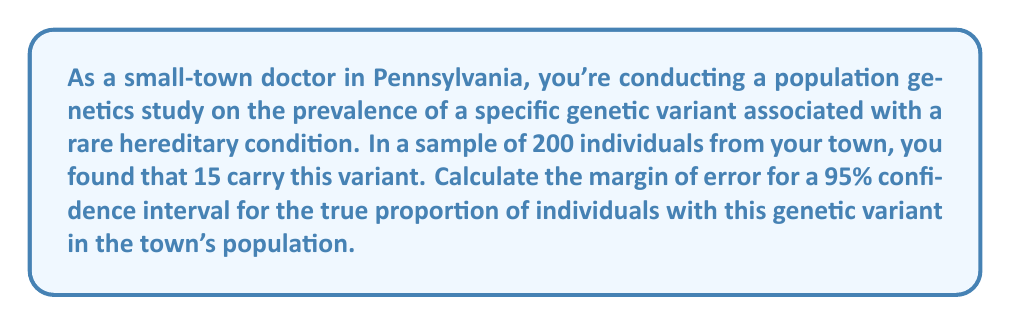Show me your answer to this math problem. Let's approach this step-by-step:

1) The margin of error (ME) for a confidence interval is calculated using the formula:

   $$ ME = z \sqrt{\frac{p(1-p)}{n}} $$

   Where:
   - $z$ is the z-score for the desired confidence level
   - $p$ is the sample proportion
   - $n$ is the sample size

2) For a 95% confidence interval, $z = 1.96$

3) Calculate the sample proportion $p$:
   $$ p = \frac{15}{200} = 0.075 $$

4) Now we can plug these values into our formula:

   $$ ME = 1.96 \sqrt{\frac{0.075(1-0.075)}{200}} $$

5) Simplify inside the square root:
   $$ ME = 1.96 \sqrt{\frac{0.075(0.925)}{200}} = 1.96 \sqrt{\frac{0.069375}{200}} $$

6) Calculate:
   $$ ME = 1.96 \sqrt{0.00034688} = 1.96 * 0.018624 = 0.0365 $$

7) Round to 3 decimal places:
   $$ ME \approx 0.037 $$

This means the margin of error is approximately 0.037 or 3.7%.
Answer: 0.037 